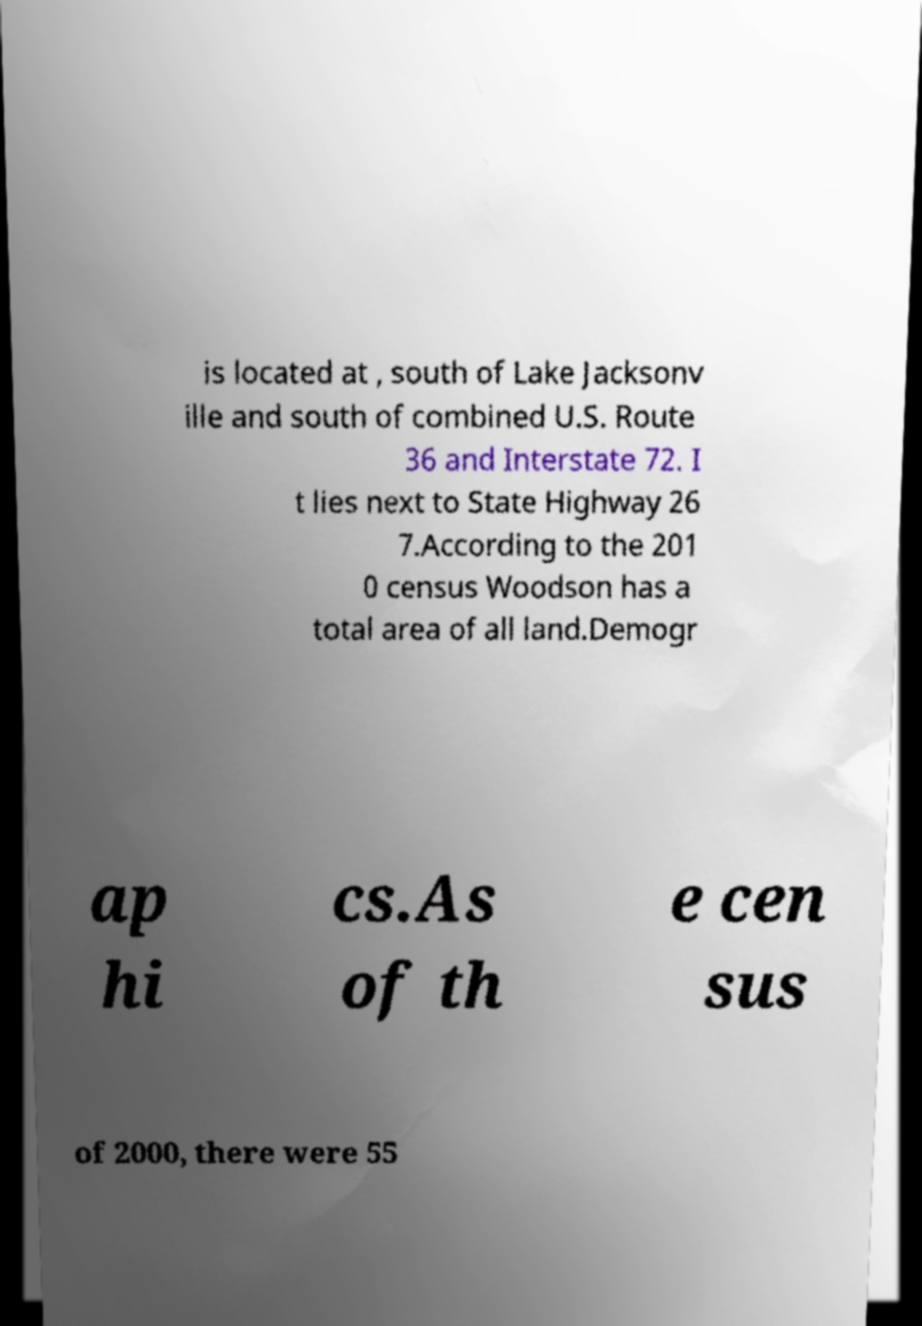For documentation purposes, I need the text within this image transcribed. Could you provide that? is located at , south of Lake Jacksonv ille and south of combined U.S. Route 36 and Interstate 72. I t lies next to State Highway 26 7.According to the 201 0 census Woodson has a total area of all land.Demogr ap hi cs.As of th e cen sus of 2000, there were 55 